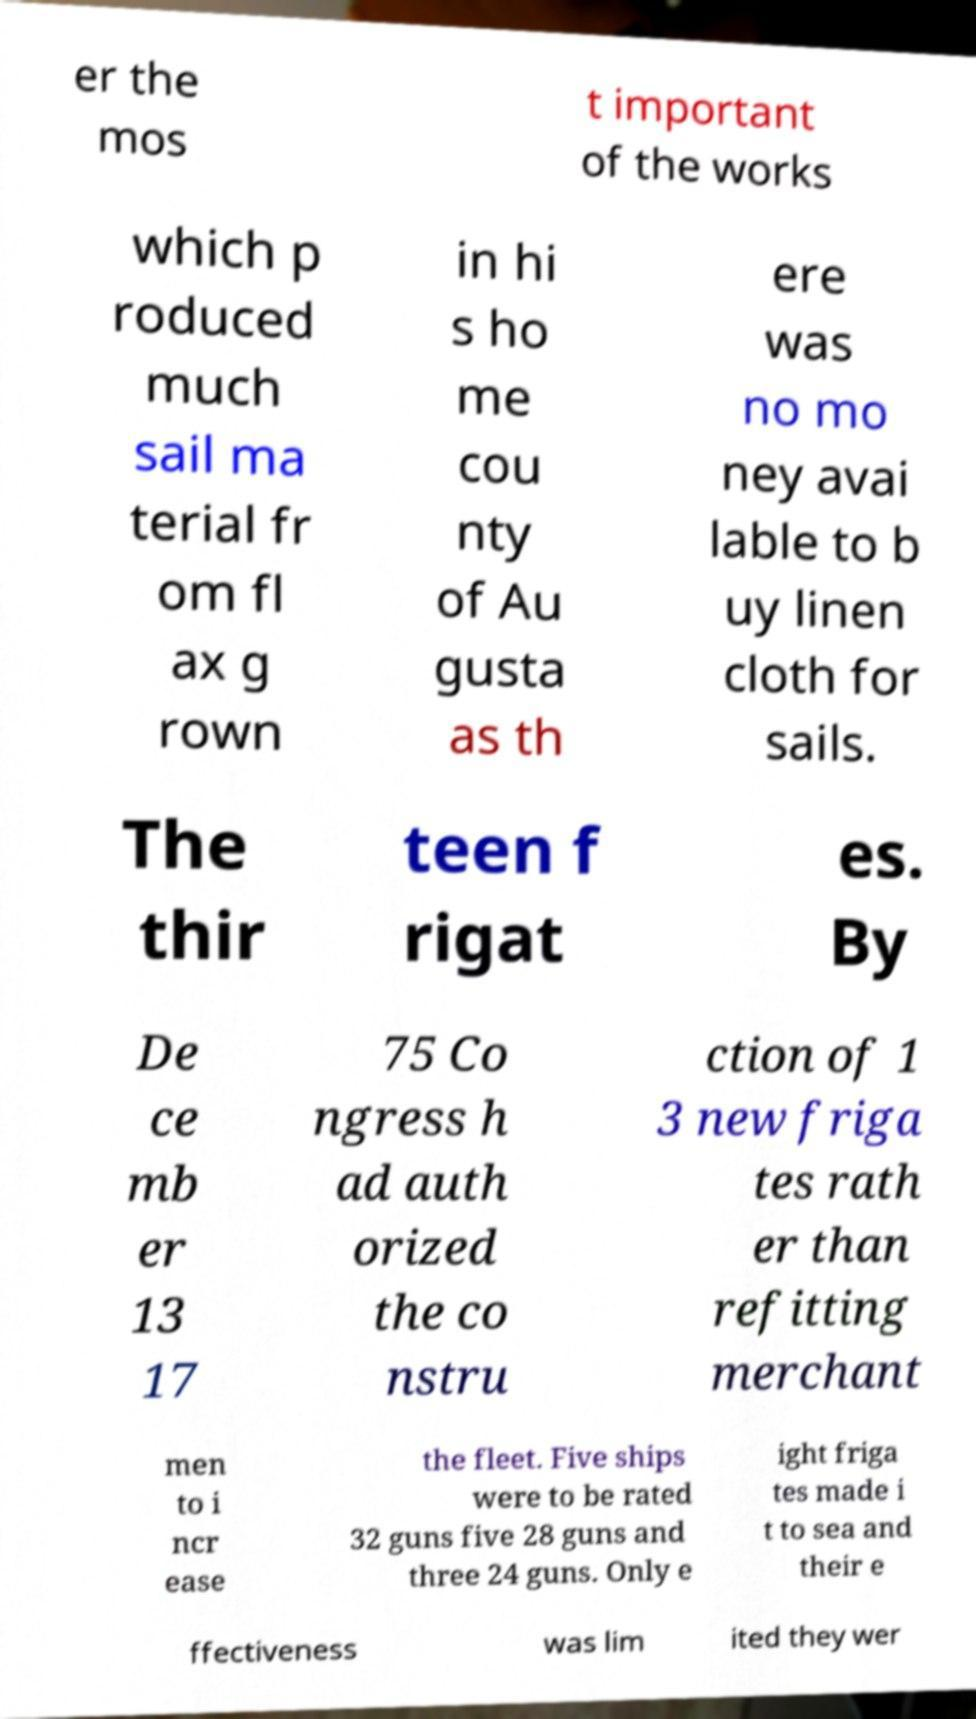Could you extract and type out the text from this image? er the mos t important of the works which p roduced much sail ma terial fr om fl ax g rown in hi s ho me cou nty of Au gusta as th ere was no mo ney avai lable to b uy linen cloth for sails. The thir teen f rigat es. By De ce mb er 13 17 75 Co ngress h ad auth orized the co nstru ction of 1 3 new friga tes rath er than refitting merchant men to i ncr ease the fleet. Five ships were to be rated 32 guns five 28 guns and three 24 guns. Only e ight friga tes made i t to sea and their e ffectiveness was lim ited they wer 